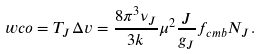Convert formula to latex. <formula><loc_0><loc_0><loc_500><loc_500>\ w c o = T _ { J } \Delta v = \frac { 8 \pi ^ { 3 } \nu _ { J } } { 3 k } \mu ^ { 2 } \frac { J } { g _ { J } } f _ { c m b } N _ { J } .</formula> 